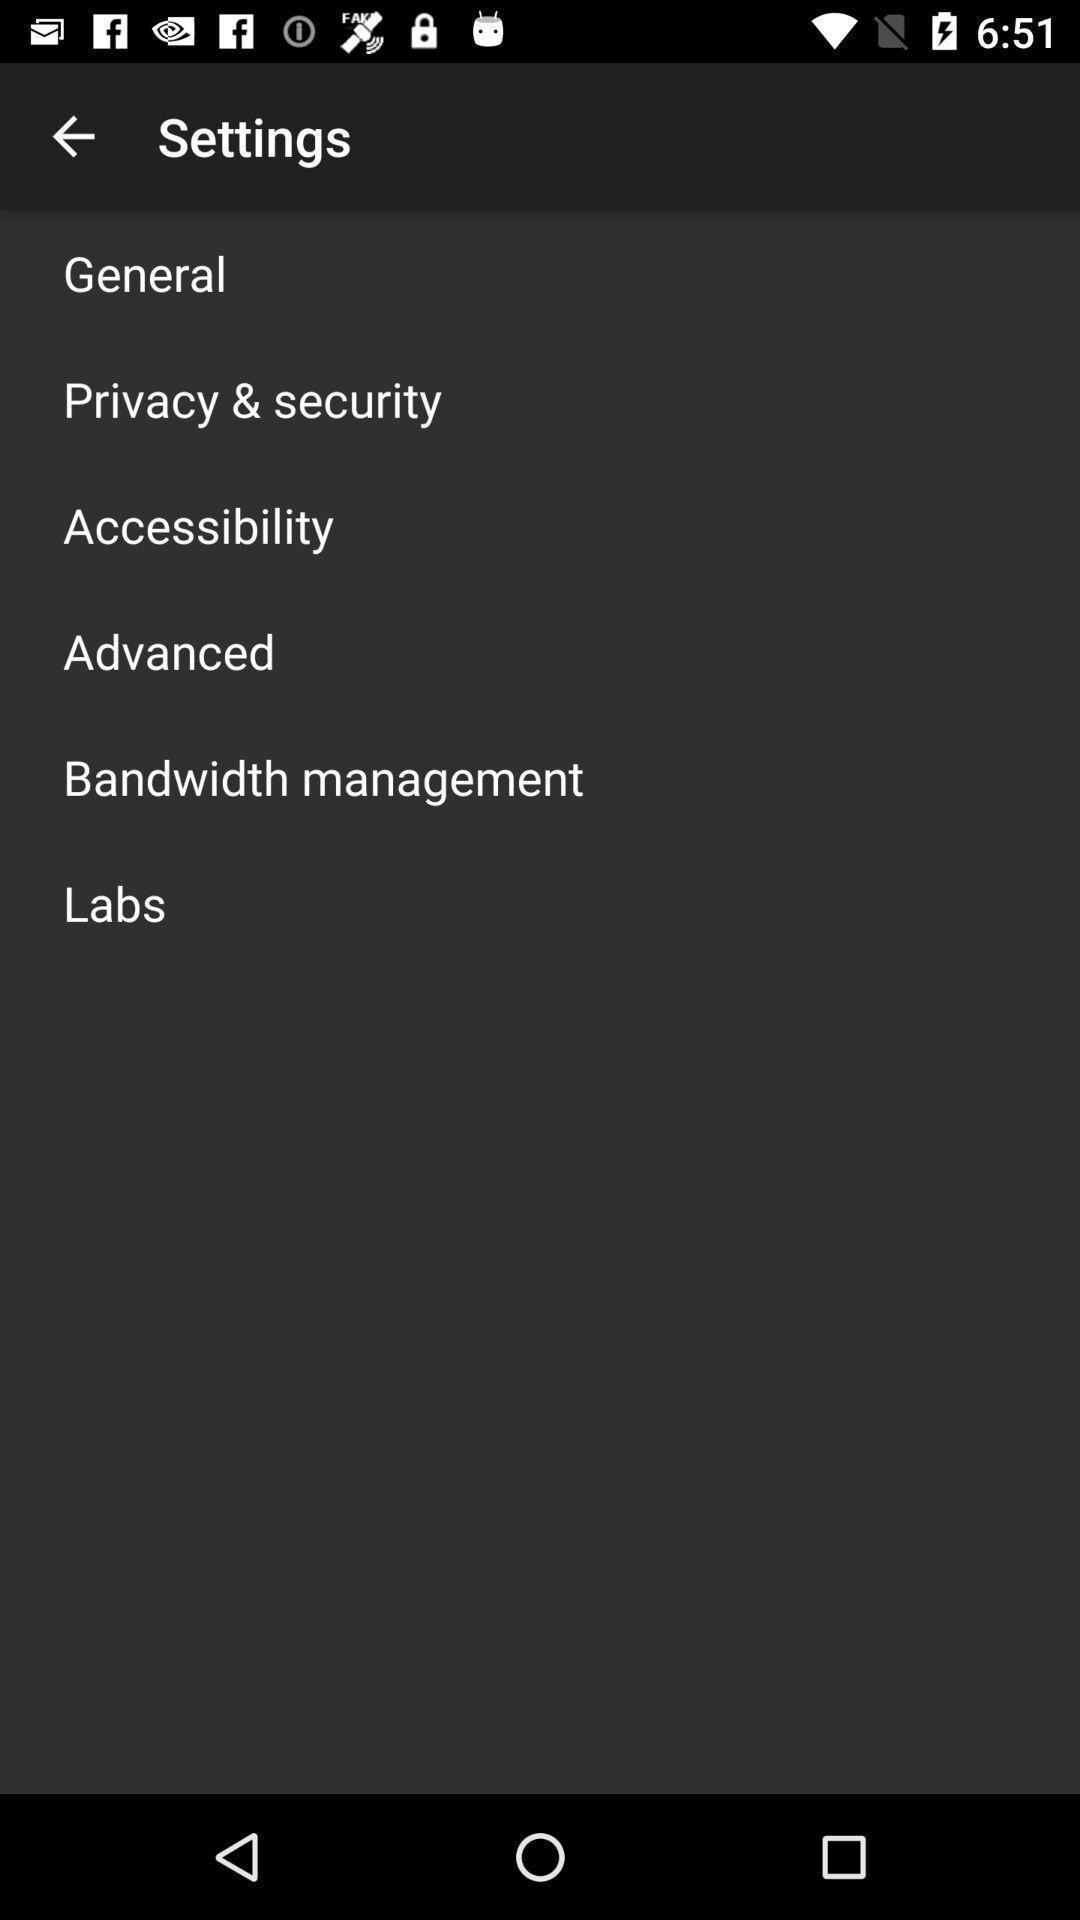Summarize the main components in this picture. Settings page with various options in fitness application. 